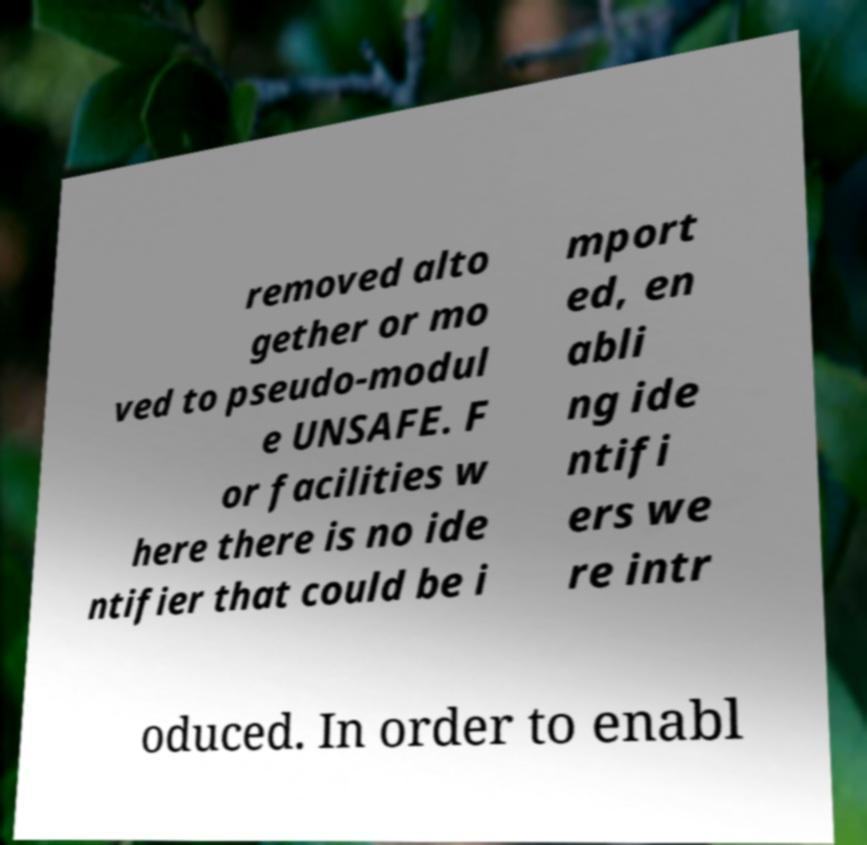I need the written content from this picture converted into text. Can you do that? removed alto gether or mo ved to pseudo-modul e UNSAFE. F or facilities w here there is no ide ntifier that could be i mport ed, en abli ng ide ntifi ers we re intr oduced. In order to enabl 